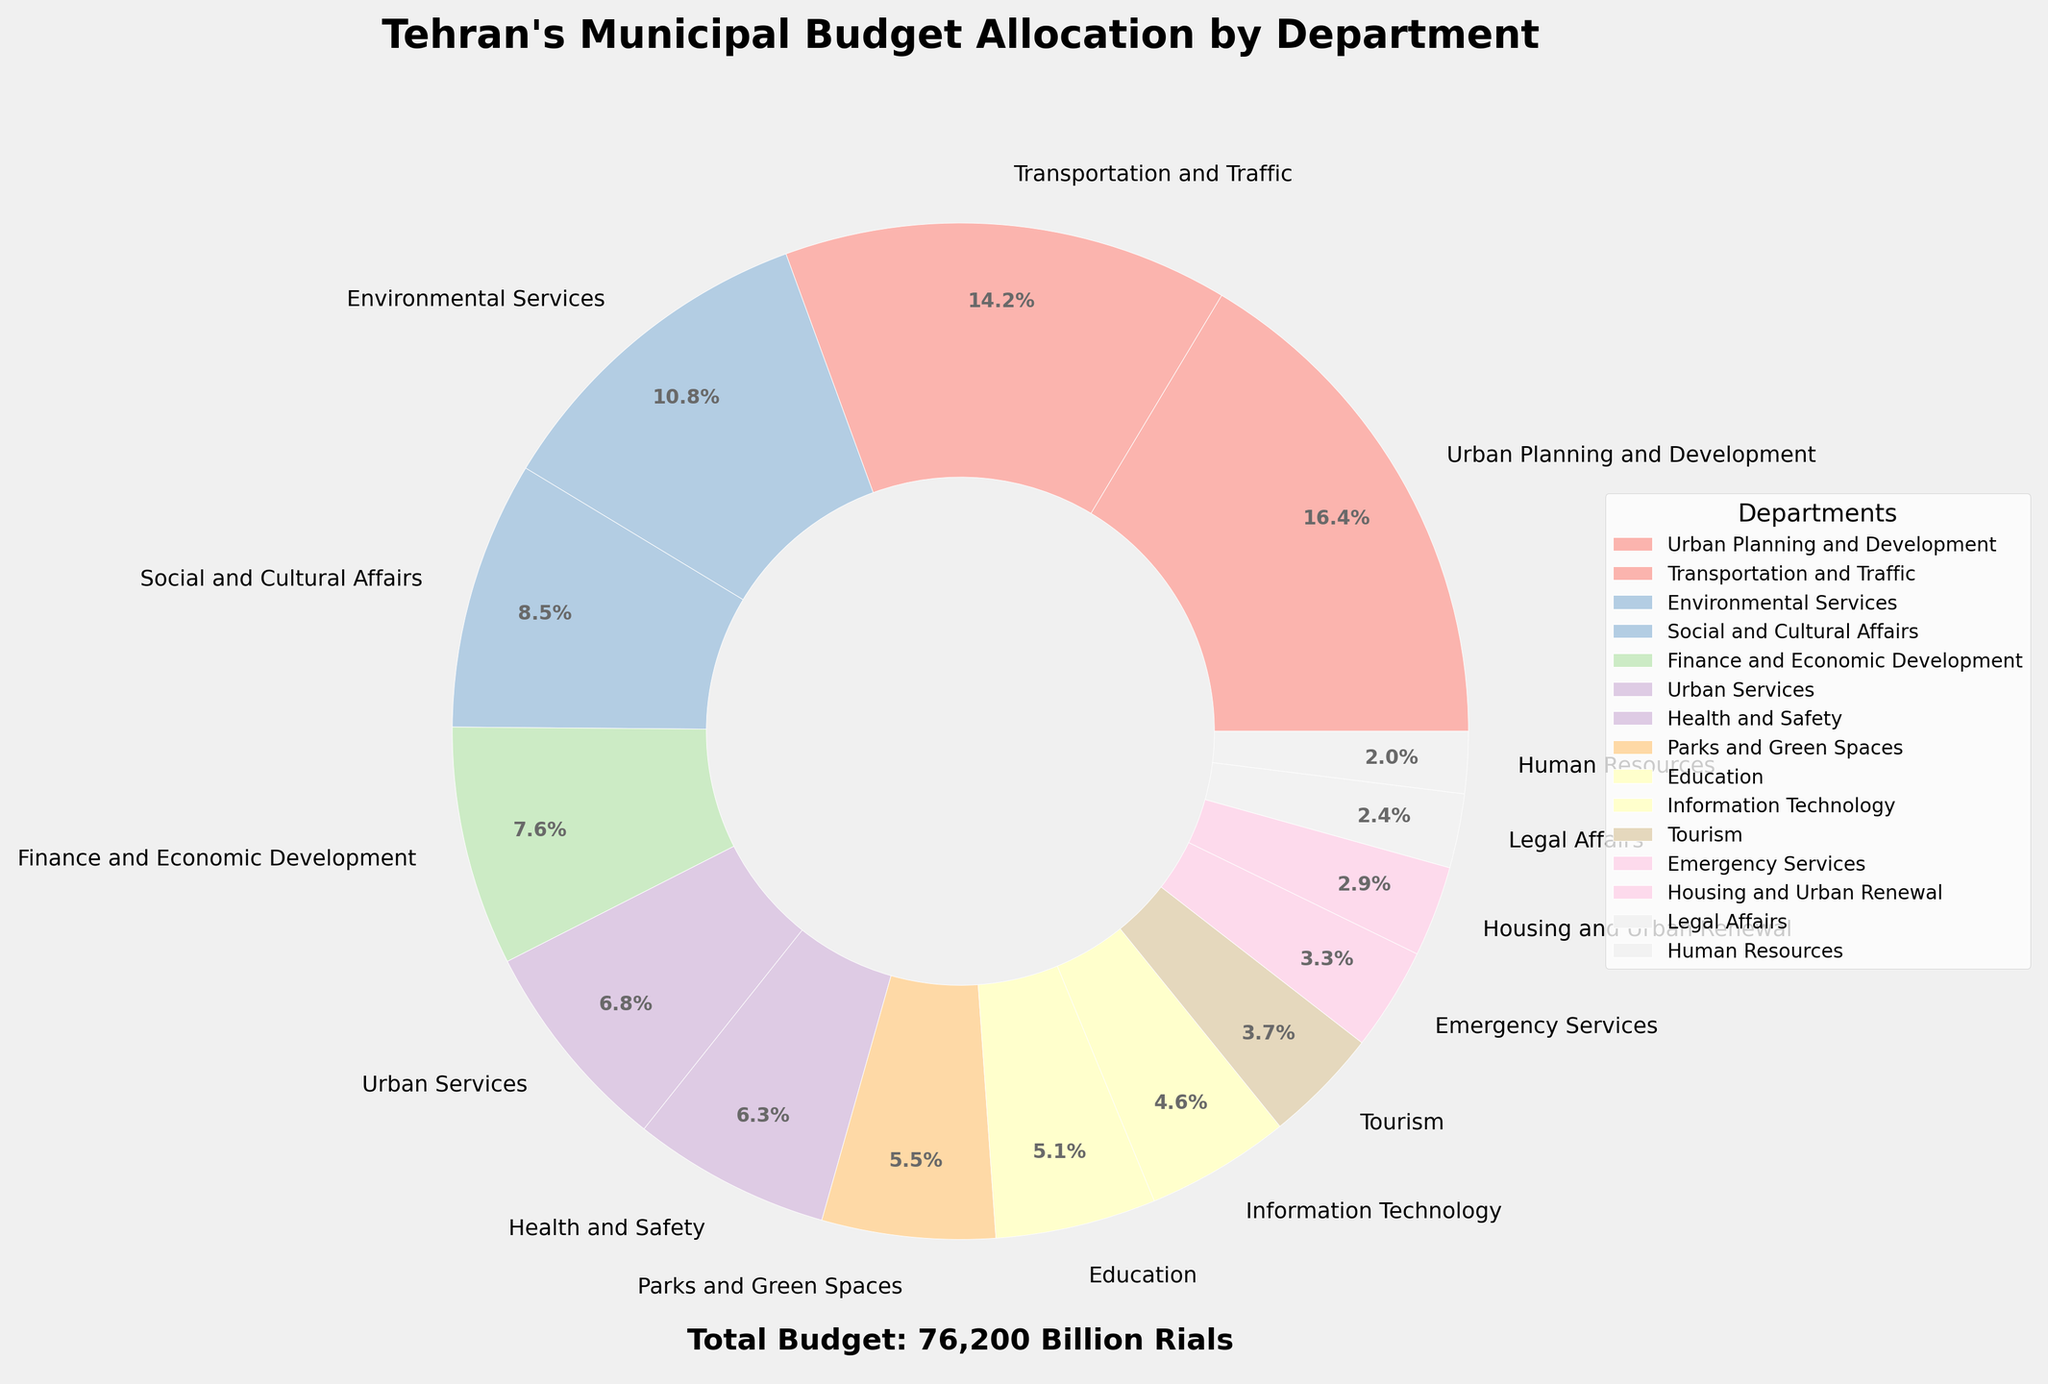Which department receives the highest portion of the budget? The largest wedge in the pie chart represents the department with the highest budget allocation. This wedge is labeled "Urban Planning and Development".
Answer: Urban Planning and Development What percentage of the budget is allocated to the two largest departments combined? The two largest wedges represent "Urban Planning and Development" and "Transportation and Traffic". Their percentages are 18.3% and 15.8% respectively. Summing these up gives 18.3% + 15.8% = 34.1%.
Answer: 34.1% Which three departments receive the smallest portion of the budget? The smallest three wedges on the pie chart are labeled "Human Resources", "Legal Affairs", and "Housing and Urban Renewal", which have noticeably smaller sizes than the other wedges.
Answer: Human Resources, Legal Affairs, Housing and Urban Renewal Is the budget allocated to Education greater than that allocated to Human Resources? The size of the wedge for "Education" is noticeably larger than that for "Human Resources". Thus, the budget allocated to Education is greater.
Answer: Yes How much more budget does Parks and Green Spaces receive compared to Tourism? We find the values for both departments: Parks and Green Spaces (4200 Billion Rials) and Tourism (2800 Billion Rials). Subtract the smaller from the larger: 4200 - 2800 = 1400 Billion Rials.
Answer: 1400 Billion Rials What is the combined budget percentage for Environmental Services and Health and Safety? The wedges for Environmental Services and Health and Safety represent 12.0% and 7.0% of the budget respectively. Adding these gives 12.0% + 7.0% = 19.0%.
Answer: 19.0% Which department receives a budget closest to 10% of the total budget? By inspecting the pie chart, the wedge labeled "Transportation and Traffic" is close to 10% with 15.8%, but "Environmental Services"" is closest to 10% with 12.0%.
Answer: Environmental Services Between Finance and Economic Development and Social and Cultural Affairs, which department has a higher budget? The wedges for "Finance and Economic Development" and "Social and Cultural Affairs" show that the latter is larger.
Answer: Social and Cultural Affairs Which color represents the Tourism department on the pie chart? By looking at the color labels and legends positioned near each wedge, you can identify the color assigned to "Tourism".
Answer: Light color (specific color varies by palette) What is the total budget allocated to Urban Services and Emergency Services combined? The values for Urban Services and Emergency Services are 5200 Billion Rials and 2500 Billion Rials, respectively. Summing these gives 5200 + 2500 = 7700 Billion Rials.
Answer: 7700 Billion Rials 